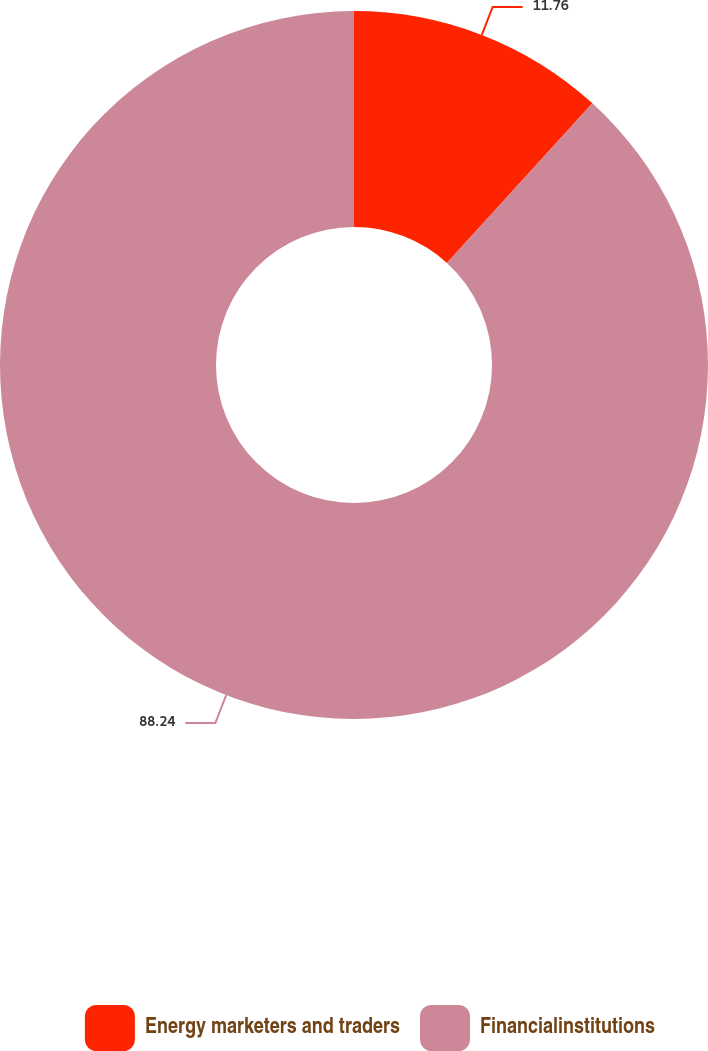Convert chart to OTSL. <chart><loc_0><loc_0><loc_500><loc_500><pie_chart><fcel>Energy marketers and traders<fcel>Financialinstitutions<nl><fcel>11.76%<fcel>88.24%<nl></chart> 